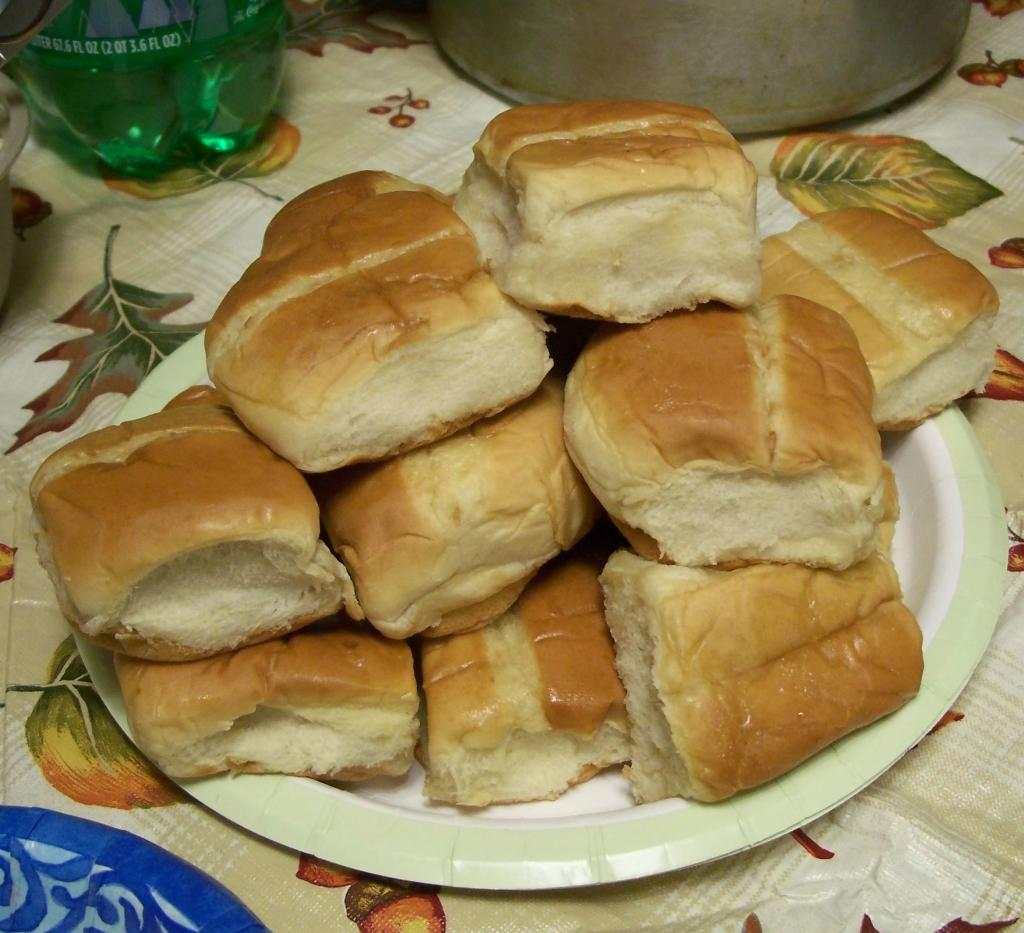What is on the plate in the image? There are food items on a plate in the image. What is under the plate? The plate is on a table mat. What other items can be seen on the table? There is a bottle, a bowl, and a container in the image. What type of floor can be seen under the table in the image? The image does not show the floor under the table, so it cannot be determined from the image. 